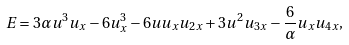<formula> <loc_0><loc_0><loc_500><loc_500>E = 3 \alpha u ^ { 3 } u _ { x } - 6 u _ { x } ^ { 3 } - 6 u u _ { x } u _ { 2 x } + 3 u ^ { 2 } u _ { 3 x } - \frac { 6 } { \alpha } u _ { x } u _ { 4 x } ,</formula> 